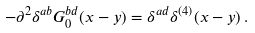Convert formula to latex. <formula><loc_0><loc_0><loc_500><loc_500>- \partial ^ { 2 } \delta ^ { a b } G _ { 0 } ^ { b d } ( x - y ) = \delta ^ { a d } \delta ^ { ( 4 ) } ( x - y ) \, .</formula> 